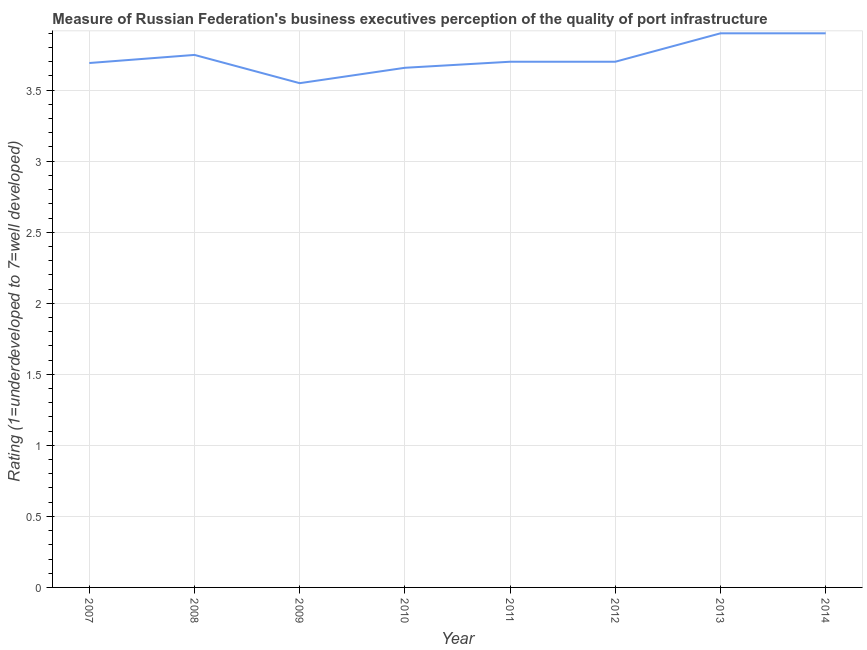What is the rating measuring quality of port infrastructure in 2011?
Your answer should be compact. 3.7. Across all years, what is the minimum rating measuring quality of port infrastructure?
Offer a terse response. 3.55. What is the sum of the rating measuring quality of port infrastructure?
Provide a succinct answer. 29.85. What is the difference between the rating measuring quality of port infrastructure in 2012 and 2014?
Make the answer very short. -0.2. What is the average rating measuring quality of port infrastructure per year?
Your answer should be compact. 3.73. What is the median rating measuring quality of port infrastructure?
Keep it short and to the point. 3.7. In how many years, is the rating measuring quality of port infrastructure greater than 3.3 ?
Make the answer very short. 8. Do a majority of the years between 2010 and 2011 (inclusive) have rating measuring quality of port infrastructure greater than 2.2 ?
Offer a very short reply. Yes. What is the ratio of the rating measuring quality of port infrastructure in 2007 to that in 2010?
Give a very brief answer. 1.01. Is the rating measuring quality of port infrastructure in 2010 less than that in 2013?
Your answer should be very brief. Yes. Is the difference between the rating measuring quality of port infrastructure in 2010 and 2011 greater than the difference between any two years?
Ensure brevity in your answer.  No. What is the difference between the highest and the second highest rating measuring quality of port infrastructure?
Ensure brevity in your answer.  0. What is the difference between the highest and the lowest rating measuring quality of port infrastructure?
Your response must be concise. 0.35. In how many years, is the rating measuring quality of port infrastructure greater than the average rating measuring quality of port infrastructure taken over all years?
Make the answer very short. 3. How many lines are there?
Your answer should be very brief. 1. Does the graph contain any zero values?
Provide a short and direct response. No. What is the title of the graph?
Your answer should be very brief. Measure of Russian Federation's business executives perception of the quality of port infrastructure. What is the label or title of the Y-axis?
Make the answer very short. Rating (1=underdeveloped to 7=well developed) . What is the Rating (1=underdeveloped to 7=well developed)  of 2007?
Keep it short and to the point. 3.69. What is the Rating (1=underdeveloped to 7=well developed)  of 2008?
Provide a succinct answer. 3.75. What is the Rating (1=underdeveloped to 7=well developed)  in 2009?
Your answer should be compact. 3.55. What is the Rating (1=underdeveloped to 7=well developed)  of 2010?
Ensure brevity in your answer.  3.66. What is the Rating (1=underdeveloped to 7=well developed)  of 2011?
Keep it short and to the point. 3.7. What is the Rating (1=underdeveloped to 7=well developed)  of 2013?
Ensure brevity in your answer.  3.9. What is the Rating (1=underdeveloped to 7=well developed)  of 2014?
Your answer should be very brief. 3.9. What is the difference between the Rating (1=underdeveloped to 7=well developed)  in 2007 and 2008?
Provide a succinct answer. -0.06. What is the difference between the Rating (1=underdeveloped to 7=well developed)  in 2007 and 2009?
Offer a terse response. 0.14. What is the difference between the Rating (1=underdeveloped to 7=well developed)  in 2007 and 2010?
Your response must be concise. 0.03. What is the difference between the Rating (1=underdeveloped to 7=well developed)  in 2007 and 2011?
Offer a very short reply. -0.01. What is the difference between the Rating (1=underdeveloped to 7=well developed)  in 2007 and 2012?
Make the answer very short. -0.01. What is the difference between the Rating (1=underdeveloped to 7=well developed)  in 2007 and 2013?
Your answer should be very brief. -0.21. What is the difference between the Rating (1=underdeveloped to 7=well developed)  in 2007 and 2014?
Ensure brevity in your answer.  -0.21. What is the difference between the Rating (1=underdeveloped to 7=well developed)  in 2008 and 2009?
Give a very brief answer. 0.2. What is the difference between the Rating (1=underdeveloped to 7=well developed)  in 2008 and 2010?
Offer a terse response. 0.09. What is the difference between the Rating (1=underdeveloped to 7=well developed)  in 2008 and 2011?
Your answer should be compact. 0.05. What is the difference between the Rating (1=underdeveloped to 7=well developed)  in 2008 and 2012?
Ensure brevity in your answer.  0.05. What is the difference between the Rating (1=underdeveloped to 7=well developed)  in 2008 and 2013?
Provide a succinct answer. -0.15. What is the difference between the Rating (1=underdeveloped to 7=well developed)  in 2008 and 2014?
Provide a short and direct response. -0.15. What is the difference between the Rating (1=underdeveloped to 7=well developed)  in 2009 and 2010?
Keep it short and to the point. -0.11. What is the difference between the Rating (1=underdeveloped to 7=well developed)  in 2009 and 2011?
Provide a short and direct response. -0.15. What is the difference between the Rating (1=underdeveloped to 7=well developed)  in 2009 and 2012?
Offer a very short reply. -0.15. What is the difference between the Rating (1=underdeveloped to 7=well developed)  in 2009 and 2013?
Keep it short and to the point. -0.35. What is the difference between the Rating (1=underdeveloped to 7=well developed)  in 2009 and 2014?
Keep it short and to the point. -0.35. What is the difference between the Rating (1=underdeveloped to 7=well developed)  in 2010 and 2011?
Make the answer very short. -0.04. What is the difference between the Rating (1=underdeveloped to 7=well developed)  in 2010 and 2012?
Offer a terse response. -0.04. What is the difference between the Rating (1=underdeveloped to 7=well developed)  in 2010 and 2013?
Give a very brief answer. -0.24. What is the difference between the Rating (1=underdeveloped to 7=well developed)  in 2010 and 2014?
Your response must be concise. -0.24. What is the difference between the Rating (1=underdeveloped to 7=well developed)  in 2011 and 2013?
Your answer should be very brief. -0.2. What is the difference between the Rating (1=underdeveloped to 7=well developed)  in 2011 and 2014?
Your answer should be very brief. -0.2. What is the difference between the Rating (1=underdeveloped to 7=well developed)  in 2012 and 2014?
Provide a succinct answer. -0.2. What is the ratio of the Rating (1=underdeveloped to 7=well developed)  in 2007 to that in 2010?
Ensure brevity in your answer.  1.01. What is the ratio of the Rating (1=underdeveloped to 7=well developed)  in 2007 to that in 2011?
Offer a very short reply. 1. What is the ratio of the Rating (1=underdeveloped to 7=well developed)  in 2007 to that in 2013?
Ensure brevity in your answer.  0.95. What is the ratio of the Rating (1=underdeveloped to 7=well developed)  in 2007 to that in 2014?
Provide a succinct answer. 0.95. What is the ratio of the Rating (1=underdeveloped to 7=well developed)  in 2008 to that in 2009?
Offer a very short reply. 1.06. What is the ratio of the Rating (1=underdeveloped to 7=well developed)  in 2009 to that in 2011?
Your answer should be very brief. 0.96. What is the ratio of the Rating (1=underdeveloped to 7=well developed)  in 2009 to that in 2013?
Provide a succinct answer. 0.91. What is the ratio of the Rating (1=underdeveloped to 7=well developed)  in 2009 to that in 2014?
Your answer should be very brief. 0.91. What is the ratio of the Rating (1=underdeveloped to 7=well developed)  in 2010 to that in 2011?
Provide a succinct answer. 0.99. What is the ratio of the Rating (1=underdeveloped to 7=well developed)  in 2010 to that in 2013?
Your response must be concise. 0.94. What is the ratio of the Rating (1=underdeveloped to 7=well developed)  in 2010 to that in 2014?
Make the answer very short. 0.94. What is the ratio of the Rating (1=underdeveloped to 7=well developed)  in 2011 to that in 2012?
Provide a succinct answer. 1. What is the ratio of the Rating (1=underdeveloped to 7=well developed)  in 2011 to that in 2013?
Your answer should be compact. 0.95. What is the ratio of the Rating (1=underdeveloped to 7=well developed)  in 2011 to that in 2014?
Offer a very short reply. 0.95. What is the ratio of the Rating (1=underdeveloped to 7=well developed)  in 2012 to that in 2013?
Offer a very short reply. 0.95. What is the ratio of the Rating (1=underdeveloped to 7=well developed)  in 2012 to that in 2014?
Your answer should be compact. 0.95. 